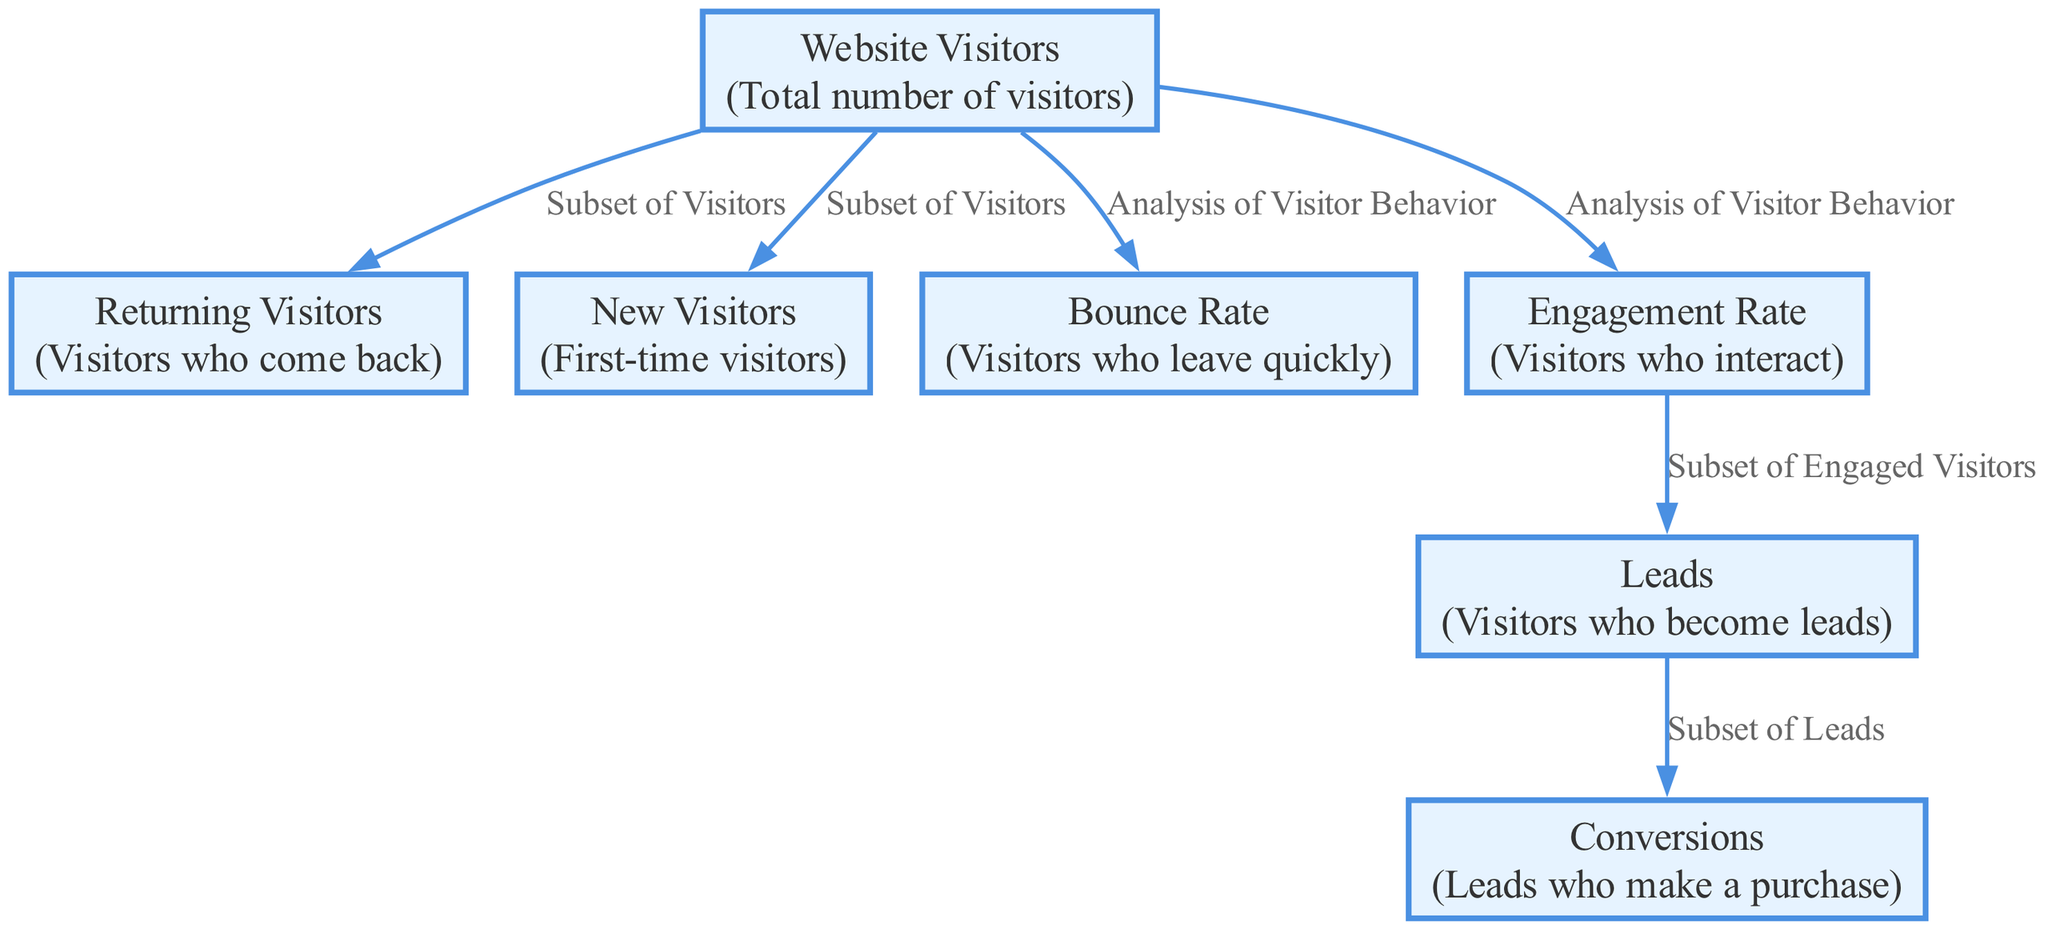What are the total number of nodes in the diagram? The diagram consists of 7 nodes: Website Visitors, Returning Visitors, New Visitors, Bounce Rate, Engagement Rate, Leads, and Conversions. Each node represents a different aspect of website user traffic patterns and conversion rates.
Answer: 7 Which node represents visitors who leave the website quickly? The node labeled "Bounce Rate" describes visitors who leave the website quickly. It is specifically the edge that connects the overall "Website Visitors" to the "Bounce Rate."
Answer: Bounce Rate What is the connection between "Engagement Rate" and "Leads"? The "Engagement Rate" node is connected to the "Leads" node, indicating a relationship where a subset of engaged visitors ultimately becomes leads. This suggests that higher engagement could lead to more leads.
Answer: Subset of Engaged Visitors How many edges are present in the diagram? There are 6 edges in the diagram, which represent the relationships between the different nodes, showcasing how various visitor types relate to each other and to conversions.
Answer: 6 What can be inferred about the relationship between "Leads" and "Conversions"? The "Leads" node is directly connected to the "Conversions" node, indicating that leads are the subset of visitors who go on to make a purchase, demonstrating a conversion from interest to actual sales.
Answer: Subset of Leads What does the term "Subset of Visitors" indicate in the diagram? The term "Subset of Visitors" appears on the edges connecting "Website Visitors" to "Returning Visitors" and "New Visitors," indicating that these groups are specific categories within the total number of website visitors.
Answer: Returning Visitors, New Visitors Why is "Engagement Rate" crucial in the context of converting visitors? "Engagement Rate" acts as a bridge connecting visitor interaction to "Leads," vital for understanding how engaged visitors translate into potential sales. Effective engagement increases the chances of generating leads.
Answer: Vital for generating leads 